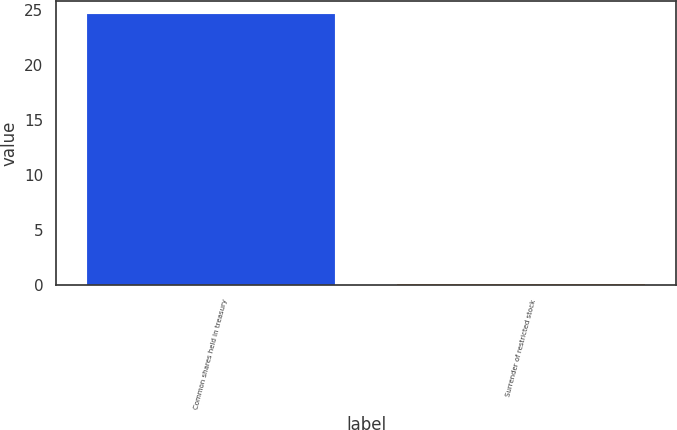Convert chart to OTSL. <chart><loc_0><loc_0><loc_500><loc_500><bar_chart><fcel>Common shares held in treasury<fcel>Surrender of restricted stock<nl><fcel>24.64<fcel>0.1<nl></chart> 